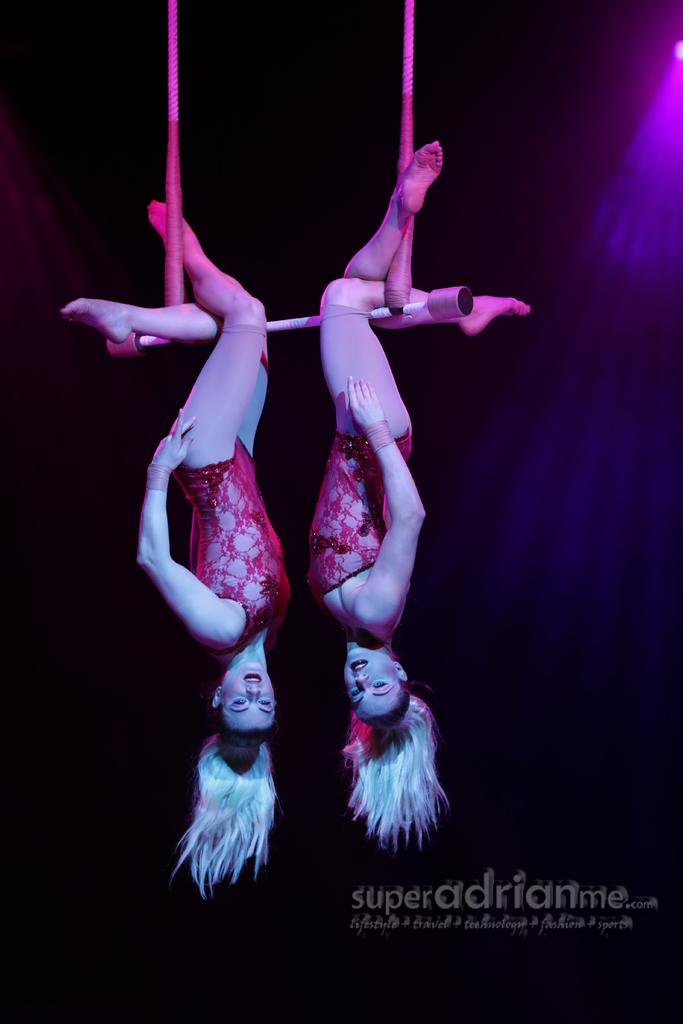How many people are in the image? There are two women in the image. What are the women doing in the image? The women are hanging upside down on a swing. What can be found at the bottom of the image? There is text at the bottom of the image. Where is the light focus in the image? There is a light focus in the top right corner of the image. How many legs does the giraffe have in the image? There is no giraffe present in the image, so it is not possible to determine the number of legs. 